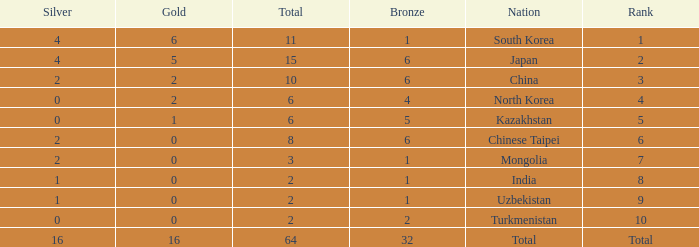What rank is Turkmenistan, who had 0 silver's and Less than 2 golds? 10.0. 